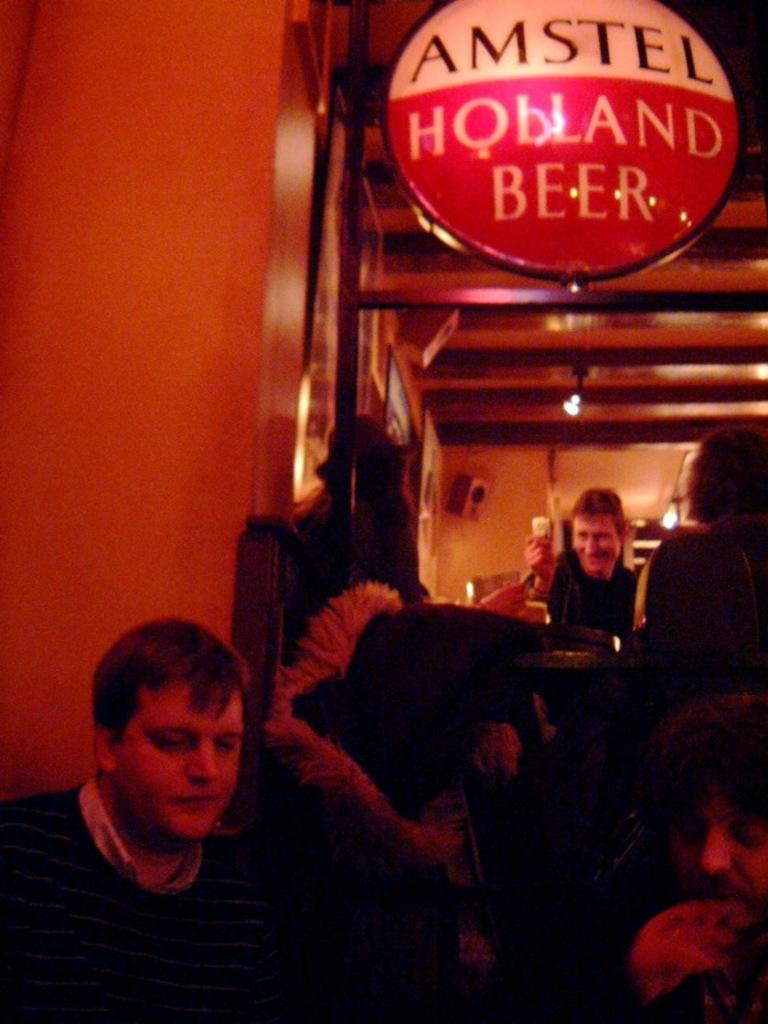How many persons are visible in the image? There are persons in the image, but the exact number is not specified. What is on the table in the image? There is cloth on a table in the image. What is the board used for in the image? The purpose of the board in the image is not specified. What type of objects are contained within the frames in the image? The contents of the frames in the image are not specified. What is the wall made of in the image? The material of the wall in the image is not specified. What type of lights are present in the image? The type of lights in the image is not specified. Can you describe the unspecified objects in the image? The unspecified objects in the image cannot be described, as they are not detailed in the provided facts. How many planes are flying in the image? There is no mention of planes in the image, so it is not possible to determine their presence or number. 